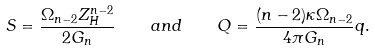Convert formula to latex. <formula><loc_0><loc_0><loc_500><loc_500>S = \frac { \Omega _ { n - 2 } Z _ { H } ^ { n - 2 } } { 2 G _ { n } } \quad a n d \quad Q = \frac { ( n - 2 ) \kappa \Omega _ { n - 2 } } { 4 \pi G _ { n } } q .</formula> 